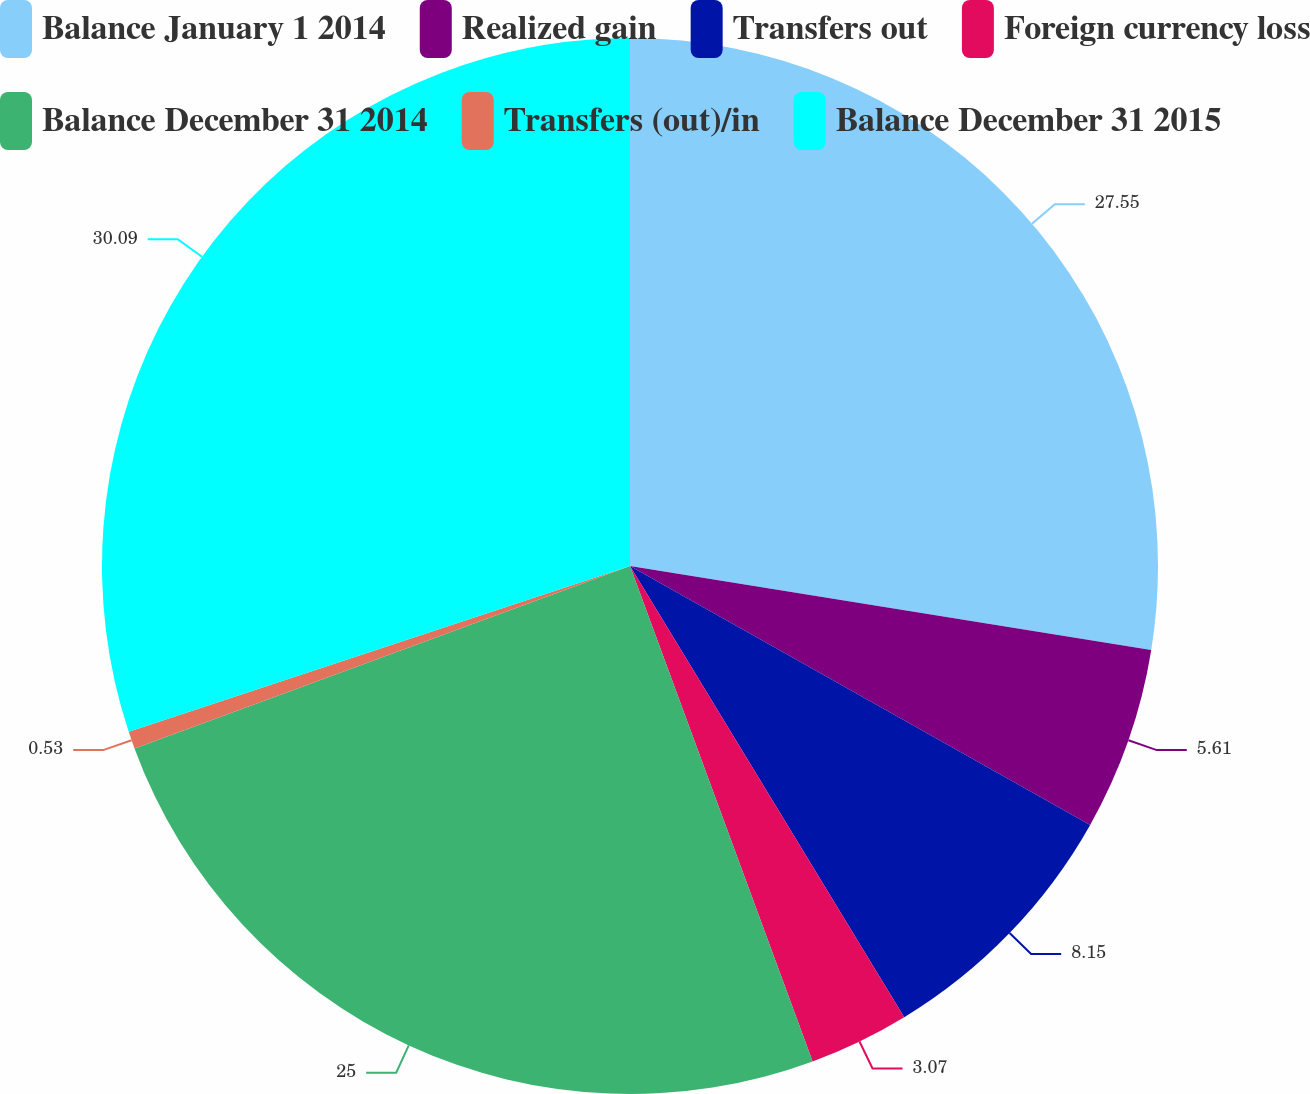<chart> <loc_0><loc_0><loc_500><loc_500><pie_chart><fcel>Balance January 1 2014<fcel>Realized gain<fcel>Transfers out<fcel>Foreign currency loss<fcel>Balance December 31 2014<fcel>Transfers (out)/in<fcel>Balance December 31 2015<nl><fcel>27.54%<fcel>5.61%<fcel>8.15%<fcel>3.07%<fcel>25.0%<fcel>0.53%<fcel>30.08%<nl></chart> 